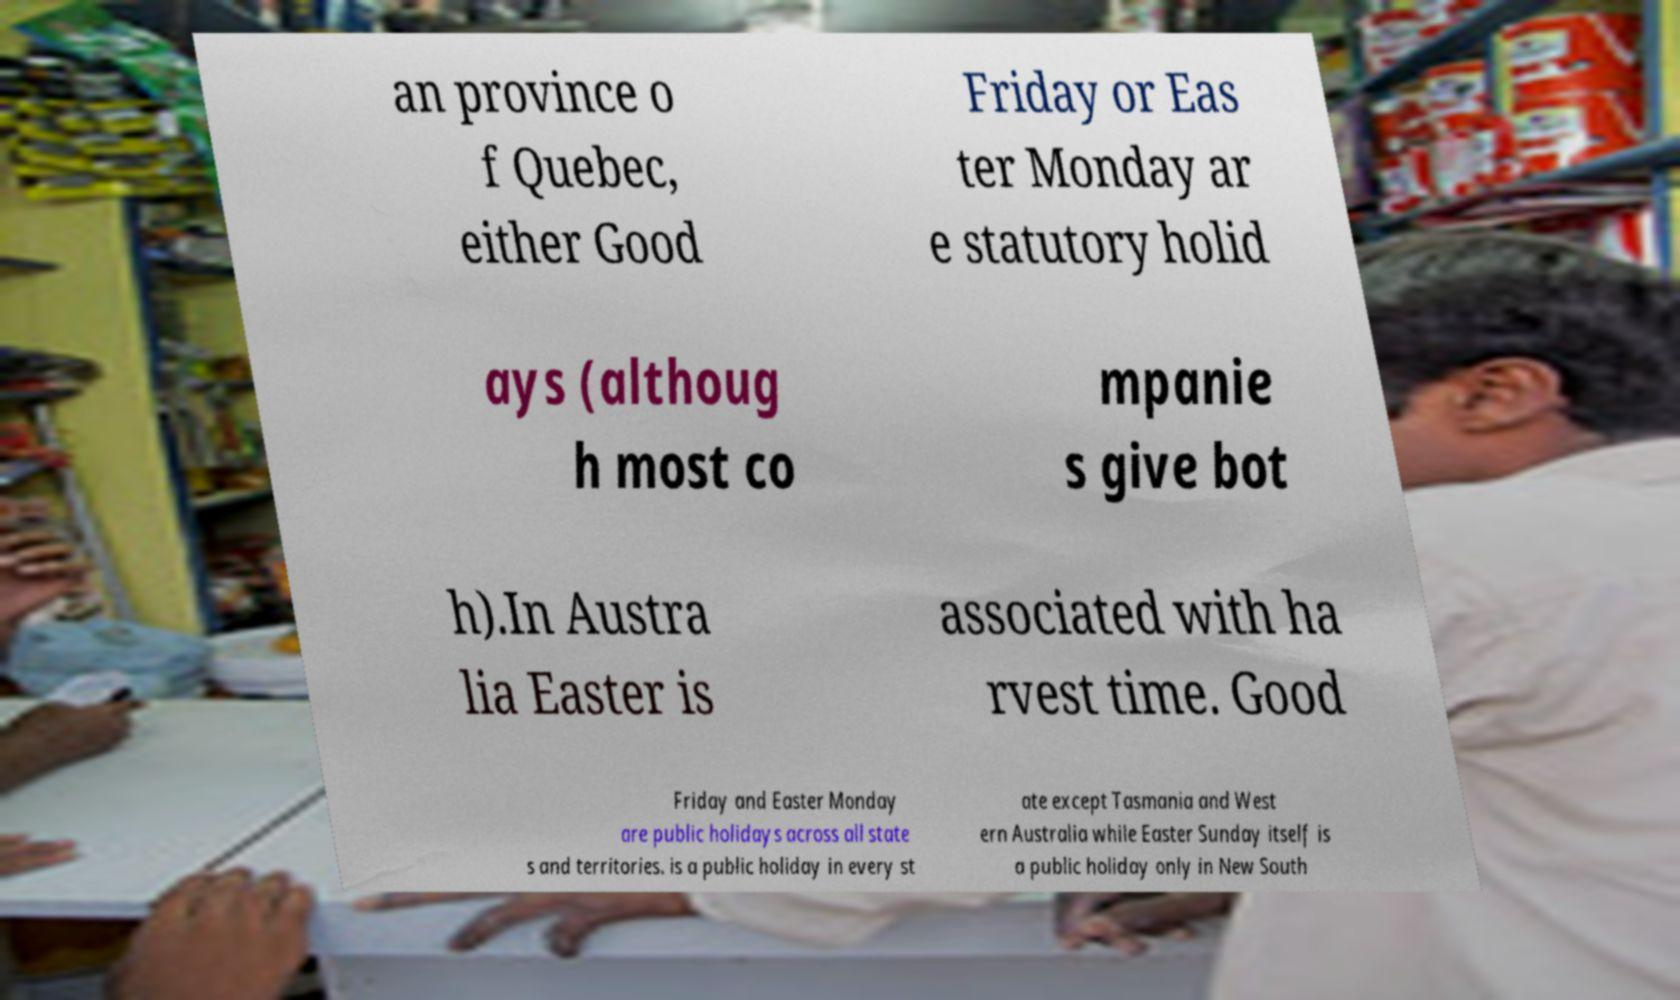Please identify and transcribe the text found in this image. an province o f Quebec, either Good Friday or Eas ter Monday ar e statutory holid ays (althoug h most co mpanie s give bot h).In Austra lia Easter is associated with ha rvest time. Good Friday and Easter Monday are public holidays across all state s and territories. is a public holiday in every st ate except Tasmania and West ern Australia while Easter Sunday itself is a public holiday only in New South 